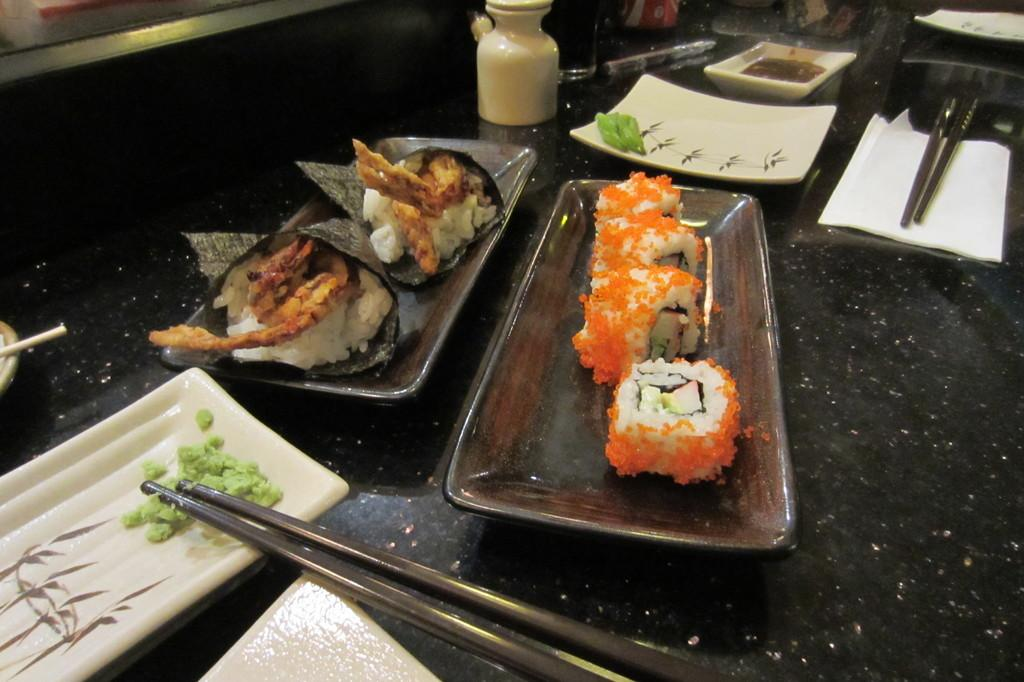What objects are on the table in the image? There are planets and food on the table in the image. What utensils are present in the image? There are chopsticks at the bottom of the image and at the top right of the image. What is located at the top of the image? There is a jar at the top of the image. What type of operation is being performed on the house in the image? There is no house or operation present in the image; it features planets, food, and chopsticks on a table. 